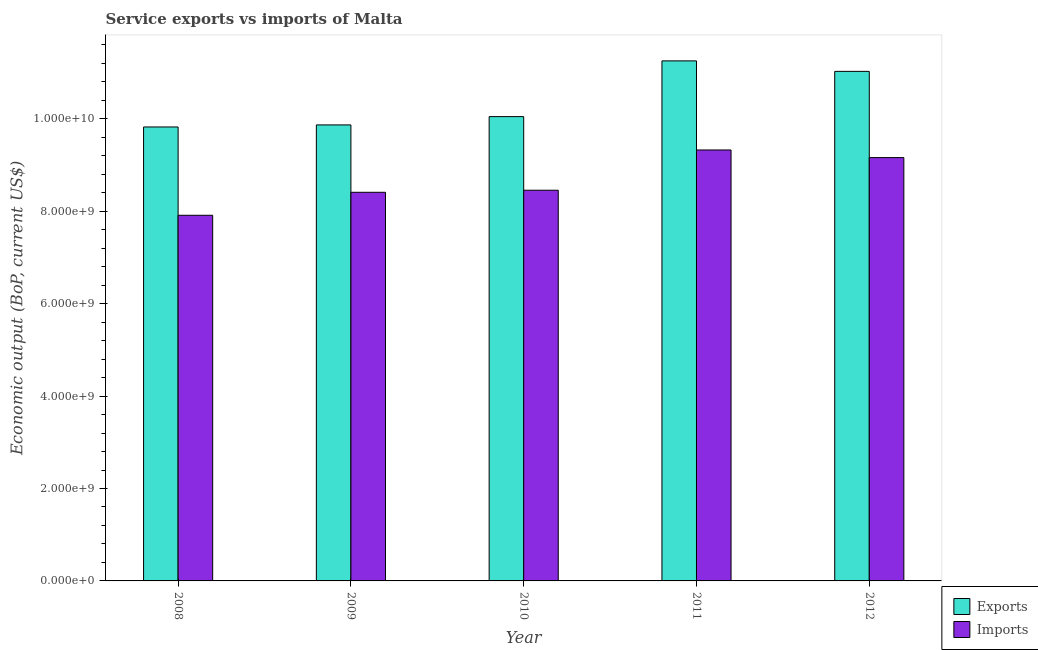How many groups of bars are there?
Ensure brevity in your answer.  5. Are the number of bars on each tick of the X-axis equal?
Your response must be concise. Yes. What is the label of the 4th group of bars from the left?
Keep it short and to the point. 2011. What is the amount of service imports in 2012?
Provide a short and direct response. 9.16e+09. Across all years, what is the maximum amount of service exports?
Ensure brevity in your answer.  1.13e+1. Across all years, what is the minimum amount of service imports?
Keep it short and to the point. 7.91e+09. What is the total amount of service imports in the graph?
Offer a terse response. 4.33e+1. What is the difference between the amount of service imports in 2009 and that in 2010?
Your response must be concise. -4.48e+07. What is the difference between the amount of service exports in 2012 and the amount of service imports in 2009?
Make the answer very short. 1.16e+09. What is the average amount of service exports per year?
Offer a very short reply. 1.04e+1. In the year 2008, what is the difference between the amount of service imports and amount of service exports?
Offer a terse response. 0. What is the ratio of the amount of service exports in 2009 to that in 2010?
Offer a very short reply. 0.98. What is the difference between the highest and the second highest amount of service imports?
Your answer should be compact. 1.65e+08. What is the difference between the highest and the lowest amount of service exports?
Make the answer very short. 1.43e+09. Is the sum of the amount of service imports in 2010 and 2012 greater than the maximum amount of service exports across all years?
Ensure brevity in your answer.  Yes. What does the 2nd bar from the left in 2011 represents?
Offer a terse response. Imports. What does the 1st bar from the right in 2010 represents?
Provide a short and direct response. Imports. Are all the bars in the graph horizontal?
Provide a short and direct response. No. What is the difference between two consecutive major ticks on the Y-axis?
Keep it short and to the point. 2.00e+09. Are the values on the major ticks of Y-axis written in scientific E-notation?
Offer a very short reply. Yes. Does the graph contain any zero values?
Offer a very short reply. No. Does the graph contain grids?
Your response must be concise. No. Where does the legend appear in the graph?
Give a very brief answer. Bottom right. How many legend labels are there?
Provide a short and direct response. 2. What is the title of the graph?
Provide a succinct answer. Service exports vs imports of Malta. What is the label or title of the X-axis?
Your answer should be compact. Year. What is the label or title of the Y-axis?
Offer a terse response. Economic output (BoP, current US$). What is the Economic output (BoP, current US$) in Exports in 2008?
Give a very brief answer. 9.82e+09. What is the Economic output (BoP, current US$) of Imports in 2008?
Give a very brief answer. 7.91e+09. What is the Economic output (BoP, current US$) in Exports in 2009?
Provide a succinct answer. 9.87e+09. What is the Economic output (BoP, current US$) in Imports in 2009?
Give a very brief answer. 8.41e+09. What is the Economic output (BoP, current US$) of Exports in 2010?
Give a very brief answer. 1.00e+1. What is the Economic output (BoP, current US$) in Imports in 2010?
Make the answer very short. 8.46e+09. What is the Economic output (BoP, current US$) in Exports in 2011?
Your response must be concise. 1.13e+1. What is the Economic output (BoP, current US$) of Imports in 2011?
Make the answer very short. 9.33e+09. What is the Economic output (BoP, current US$) in Exports in 2012?
Offer a terse response. 1.10e+1. What is the Economic output (BoP, current US$) of Imports in 2012?
Keep it short and to the point. 9.16e+09. Across all years, what is the maximum Economic output (BoP, current US$) of Exports?
Your answer should be compact. 1.13e+1. Across all years, what is the maximum Economic output (BoP, current US$) in Imports?
Your answer should be compact. 9.33e+09. Across all years, what is the minimum Economic output (BoP, current US$) of Exports?
Provide a succinct answer. 9.82e+09. Across all years, what is the minimum Economic output (BoP, current US$) of Imports?
Your response must be concise. 7.91e+09. What is the total Economic output (BoP, current US$) in Exports in the graph?
Provide a succinct answer. 5.20e+1. What is the total Economic output (BoP, current US$) in Imports in the graph?
Provide a short and direct response. 4.33e+1. What is the difference between the Economic output (BoP, current US$) in Exports in 2008 and that in 2009?
Provide a short and direct response. -4.46e+07. What is the difference between the Economic output (BoP, current US$) in Imports in 2008 and that in 2009?
Provide a succinct answer. -4.97e+08. What is the difference between the Economic output (BoP, current US$) of Exports in 2008 and that in 2010?
Give a very brief answer. -2.24e+08. What is the difference between the Economic output (BoP, current US$) of Imports in 2008 and that in 2010?
Offer a terse response. -5.42e+08. What is the difference between the Economic output (BoP, current US$) of Exports in 2008 and that in 2011?
Offer a very short reply. -1.43e+09. What is the difference between the Economic output (BoP, current US$) in Imports in 2008 and that in 2011?
Provide a short and direct response. -1.41e+09. What is the difference between the Economic output (BoP, current US$) of Exports in 2008 and that in 2012?
Provide a succinct answer. -1.20e+09. What is the difference between the Economic output (BoP, current US$) of Imports in 2008 and that in 2012?
Offer a terse response. -1.25e+09. What is the difference between the Economic output (BoP, current US$) of Exports in 2009 and that in 2010?
Provide a short and direct response. -1.80e+08. What is the difference between the Economic output (BoP, current US$) in Imports in 2009 and that in 2010?
Keep it short and to the point. -4.48e+07. What is the difference between the Economic output (BoP, current US$) in Exports in 2009 and that in 2011?
Ensure brevity in your answer.  -1.39e+09. What is the difference between the Economic output (BoP, current US$) in Imports in 2009 and that in 2011?
Ensure brevity in your answer.  -9.16e+08. What is the difference between the Economic output (BoP, current US$) of Exports in 2009 and that in 2012?
Your answer should be very brief. -1.16e+09. What is the difference between the Economic output (BoP, current US$) in Imports in 2009 and that in 2012?
Make the answer very short. -7.51e+08. What is the difference between the Economic output (BoP, current US$) in Exports in 2010 and that in 2011?
Offer a terse response. -1.21e+09. What is the difference between the Economic output (BoP, current US$) of Imports in 2010 and that in 2011?
Your answer should be very brief. -8.71e+08. What is the difference between the Economic output (BoP, current US$) of Exports in 2010 and that in 2012?
Your answer should be compact. -9.79e+08. What is the difference between the Economic output (BoP, current US$) in Imports in 2010 and that in 2012?
Offer a very short reply. -7.06e+08. What is the difference between the Economic output (BoP, current US$) in Exports in 2011 and that in 2012?
Give a very brief answer. 2.27e+08. What is the difference between the Economic output (BoP, current US$) of Imports in 2011 and that in 2012?
Your answer should be compact. 1.65e+08. What is the difference between the Economic output (BoP, current US$) of Exports in 2008 and the Economic output (BoP, current US$) of Imports in 2009?
Offer a terse response. 1.41e+09. What is the difference between the Economic output (BoP, current US$) in Exports in 2008 and the Economic output (BoP, current US$) in Imports in 2010?
Ensure brevity in your answer.  1.37e+09. What is the difference between the Economic output (BoP, current US$) of Exports in 2008 and the Economic output (BoP, current US$) of Imports in 2011?
Ensure brevity in your answer.  4.98e+08. What is the difference between the Economic output (BoP, current US$) in Exports in 2008 and the Economic output (BoP, current US$) in Imports in 2012?
Ensure brevity in your answer.  6.63e+08. What is the difference between the Economic output (BoP, current US$) in Exports in 2009 and the Economic output (BoP, current US$) in Imports in 2010?
Your answer should be compact. 1.41e+09. What is the difference between the Economic output (BoP, current US$) in Exports in 2009 and the Economic output (BoP, current US$) in Imports in 2011?
Provide a succinct answer. 5.42e+08. What is the difference between the Economic output (BoP, current US$) in Exports in 2009 and the Economic output (BoP, current US$) in Imports in 2012?
Your response must be concise. 7.07e+08. What is the difference between the Economic output (BoP, current US$) of Exports in 2010 and the Economic output (BoP, current US$) of Imports in 2011?
Offer a terse response. 7.22e+08. What is the difference between the Economic output (BoP, current US$) of Exports in 2010 and the Economic output (BoP, current US$) of Imports in 2012?
Your response must be concise. 8.87e+08. What is the difference between the Economic output (BoP, current US$) of Exports in 2011 and the Economic output (BoP, current US$) of Imports in 2012?
Provide a succinct answer. 2.09e+09. What is the average Economic output (BoP, current US$) in Exports per year?
Provide a short and direct response. 1.04e+1. What is the average Economic output (BoP, current US$) of Imports per year?
Provide a short and direct response. 8.65e+09. In the year 2008, what is the difference between the Economic output (BoP, current US$) of Exports and Economic output (BoP, current US$) of Imports?
Offer a very short reply. 1.91e+09. In the year 2009, what is the difference between the Economic output (BoP, current US$) of Exports and Economic output (BoP, current US$) of Imports?
Provide a short and direct response. 1.46e+09. In the year 2010, what is the difference between the Economic output (BoP, current US$) in Exports and Economic output (BoP, current US$) in Imports?
Your response must be concise. 1.59e+09. In the year 2011, what is the difference between the Economic output (BoP, current US$) of Exports and Economic output (BoP, current US$) of Imports?
Your response must be concise. 1.93e+09. In the year 2012, what is the difference between the Economic output (BoP, current US$) in Exports and Economic output (BoP, current US$) in Imports?
Offer a terse response. 1.87e+09. What is the ratio of the Economic output (BoP, current US$) of Exports in 2008 to that in 2009?
Ensure brevity in your answer.  1. What is the ratio of the Economic output (BoP, current US$) in Imports in 2008 to that in 2009?
Provide a short and direct response. 0.94. What is the ratio of the Economic output (BoP, current US$) in Exports in 2008 to that in 2010?
Make the answer very short. 0.98. What is the ratio of the Economic output (BoP, current US$) of Imports in 2008 to that in 2010?
Your answer should be compact. 0.94. What is the ratio of the Economic output (BoP, current US$) of Exports in 2008 to that in 2011?
Give a very brief answer. 0.87. What is the ratio of the Economic output (BoP, current US$) in Imports in 2008 to that in 2011?
Give a very brief answer. 0.85. What is the ratio of the Economic output (BoP, current US$) of Exports in 2008 to that in 2012?
Provide a short and direct response. 0.89. What is the ratio of the Economic output (BoP, current US$) of Imports in 2008 to that in 2012?
Offer a terse response. 0.86. What is the ratio of the Economic output (BoP, current US$) in Exports in 2009 to that in 2010?
Give a very brief answer. 0.98. What is the ratio of the Economic output (BoP, current US$) in Exports in 2009 to that in 2011?
Your response must be concise. 0.88. What is the ratio of the Economic output (BoP, current US$) in Imports in 2009 to that in 2011?
Offer a very short reply. 0.9. What is the ratio of the Economic output (BoP, current US$) in Exports in 2009 to that in 2012?
Offer a very short reply. 0.89. What is the ratio of the Economic output (BoP, current US$) in Imports in 2009 to that in 2012?
Ensure brevity in your answer.  0.92. What is the ratio of the Economic output (BoP, current US$) of Exports in 2010 to that in 2011?
Provide a short and direct response. 0.89. What is the ratio of the Economic output (BoP, current US$) of Imports in 2010 to that in 2011?
Give a very brief answer. 0.91. What is the ratio of the Economic output (BoP, current US$) of Exports in 2010 to that in 2012?
Provide a short and direct response. 0.91. What is the ratio of the Economic output (BoP, current US$) of Imports in 2010 to that in 2012?
Provide a short and direct response. 0.92. What is the ratio of the Economic output (BoP, current US$) in Exports in 2011 to that in 2012?
Your response must be concise. 1.02. What is the ratio of the Economic output (BoP, current US$) of Imports in 2011 to that in 2012?
Give a very brief answer. 1.02. What is the difference between the highest and the second highest Economic output (BoP, current US$) in Exports?
Make the answer very short. 2.27e+08. What is the difference between the highest and the second highest Economic output (BoP, current US$) of Imports?
Your response must be concise. 1.65e+08. What is the difference between the highest and the lowest Economic output (BoP, current US$) of Exports?
Keep it short and to the point. 1.43e+09. What is the difference between the highest and the lowest Economic output (BoP, current US$) of Imports?
Offer a terse response. 1.41e+09. 